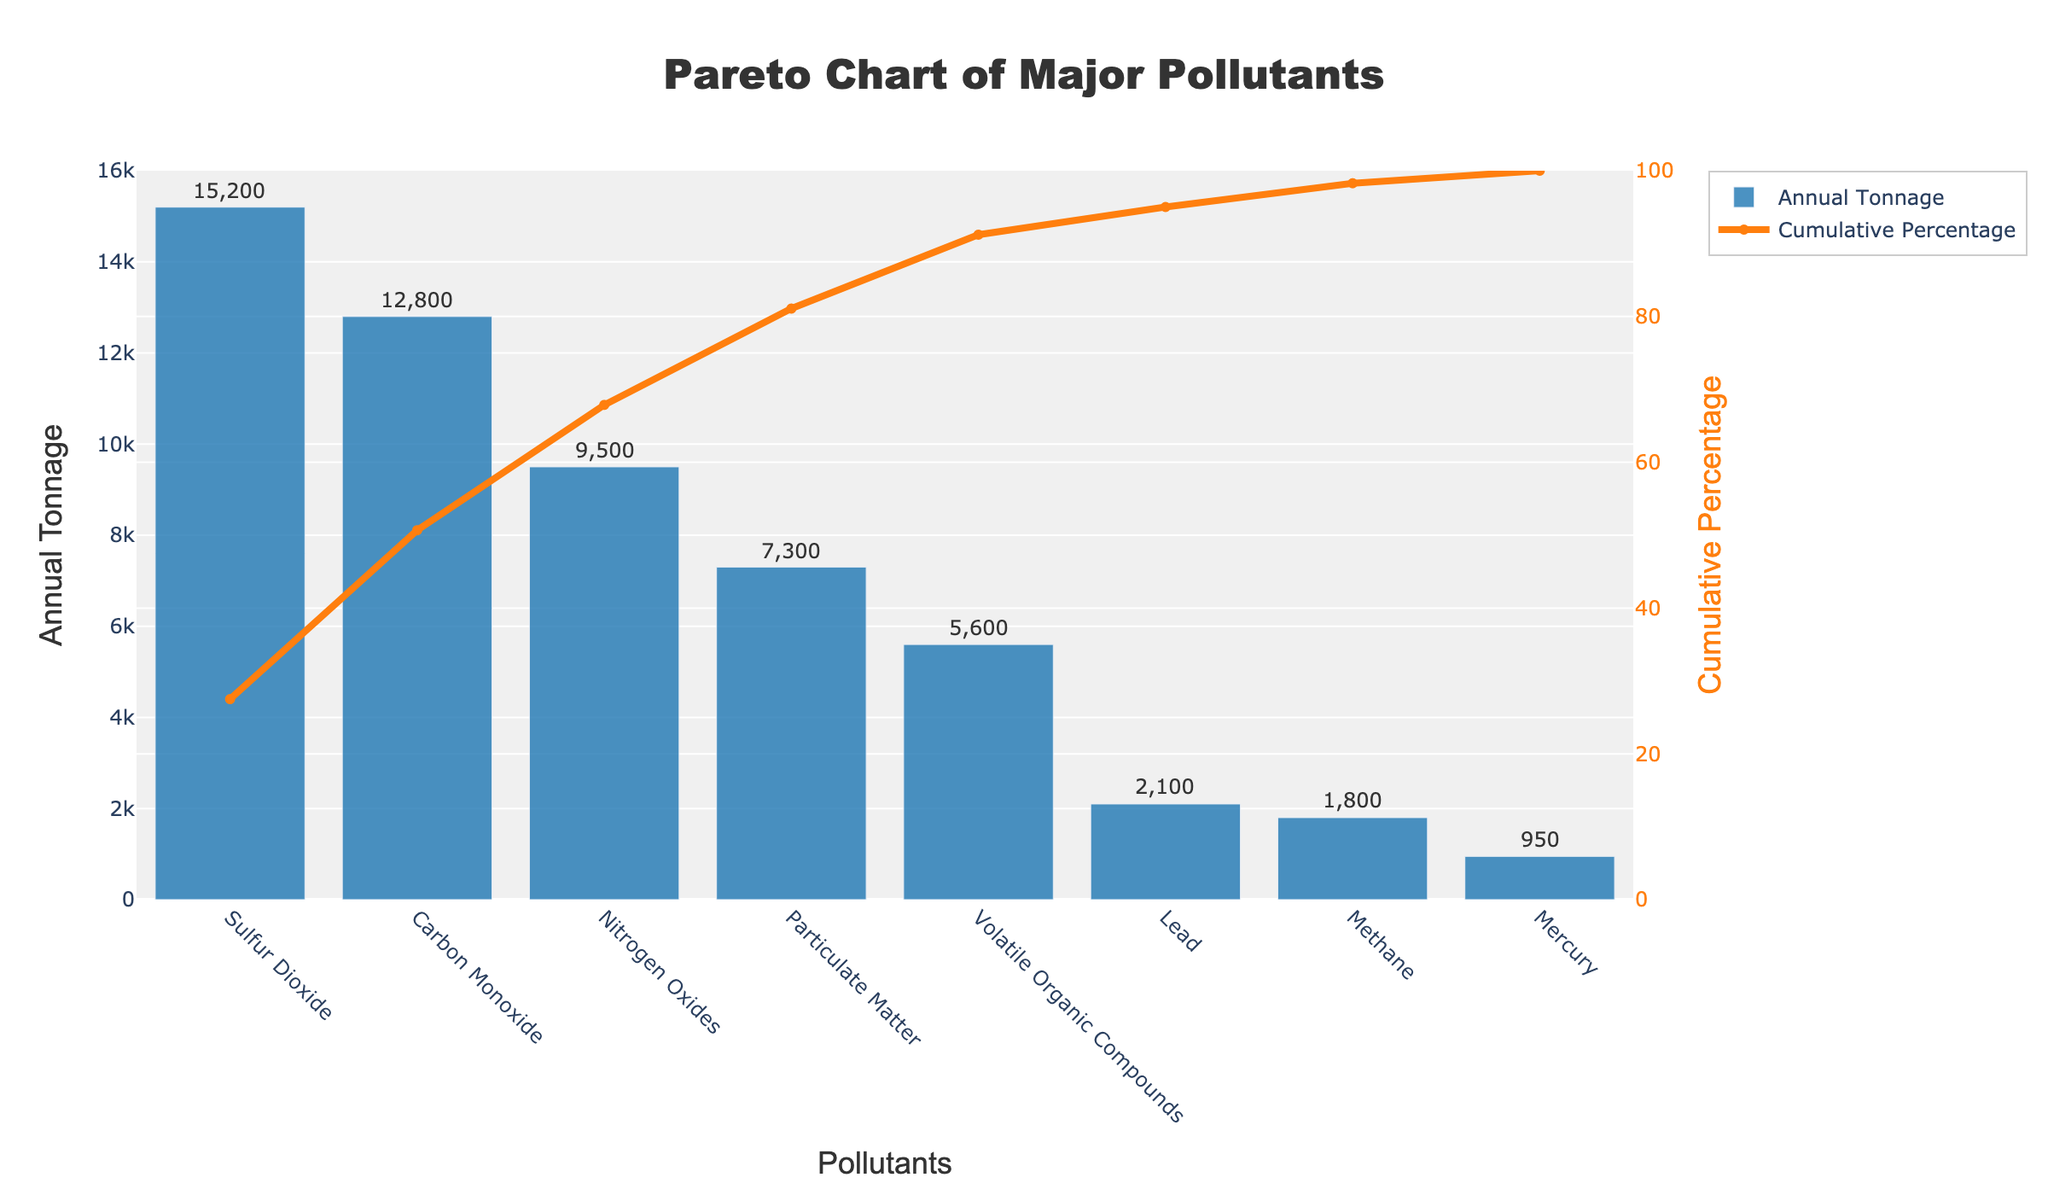What is the title of the chart? The title of the chart is displayed at the top and reads "Pareto Chart of Major Pollutants".
Answer: Pareto Chart of Major Pollutants Which pollutant has the highest annual tonnage? The pollutant with the highest annual tonnage is displayed as the first bar on the x-axis, which is Sulfur Dioxide with 15,200 tons.
Answer: Sulfur Dioxide How many pollutants have an annual tonnage above 5,000? By examining the y-axis values and bars, the pollutants with an annual tonnage above 5,000 are Sulfur Dioxide, Carbon Monoxide, Nitrogen Oxides, Particulate Matter, and Volatile Organic Compounds, making a total of 5 pollutants.
Answer: 5 What is the cumulative percentage for Nitrogen Oxides? The cumulative percentage line above Nitrogen Oxides on the x-axis shows the cumulative value, which is approximately 68%.
Answer: Approximately 68% Compare the annual tonnage of Lead with Methane. Which one is higher? By comparing the heights of the bars for Lead and Methane on the figure, the Lead annual tonnage is 2,100, which is higher than Methane's 1,800.
Answer: Lead What percentage of the total annual tonnage is contributed by the top two pollutants? Sulfur Dioxide and Carbon Monoxide contribute 15,200 and 12,800 tons respectively. The total annual tonnage is 47,250 tons, so their combined contribution is (15200 + 12800) / 47250 * 100 = approximately 59.3%.
Answer: Approximately 59.3% How many pollutants need to be addressed to reduce 80% of the total emissions? By examining the cumulative percentage line, to achieve an 80% reduction, pollutants up to Particulate Matter (4 pollutants) need to be addressed.
Answer: 4 What is the annual tonnage of Mercury, and how does it compare to Methane? The annual tonnage of Mercury is 950 tons, while Methane is 1,800 tons. Methane has a higher annual tonnage than Mercury.
Answer: Methane has a higher annual tonnage If you were to rank Lead in terms of cumulative percentage, what would it be? Find the position of Lead on the x-axis and look at the cumulative percentage line, which is around 94%.
Answer: Around 94% What is the difference in annual tonnage between the highest and lowest emitting pollutants? The highest emitting pollutant is Sulfur Dioxide with 15,200 tons, and the lowest is Mercury with 950 tons. The difference is 15,200 - 950 = 14,250 tons.
Answer: 14,250 tons 